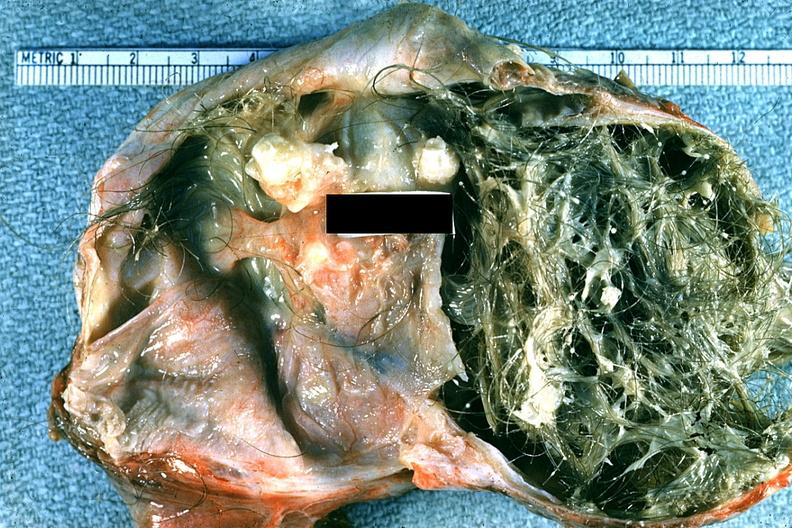what is present?
Answer the question using a single word or phrase. Female reproductive 